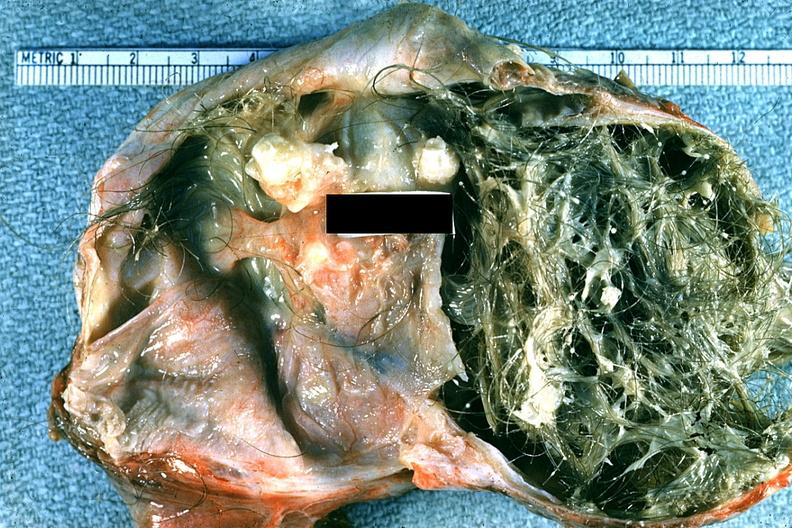what is present?
Answer the question using a single word or phrase. Female reproductive 